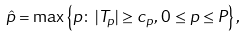Convert formula to latex. <formula><loc_0><loc_0><loc_500><loc_500>\hat { p } = \max \left \{ p \colon \, | T _ { p } | \geq c _ { p } , \, 0 \leq p \leq P \right \} ,</formula> 